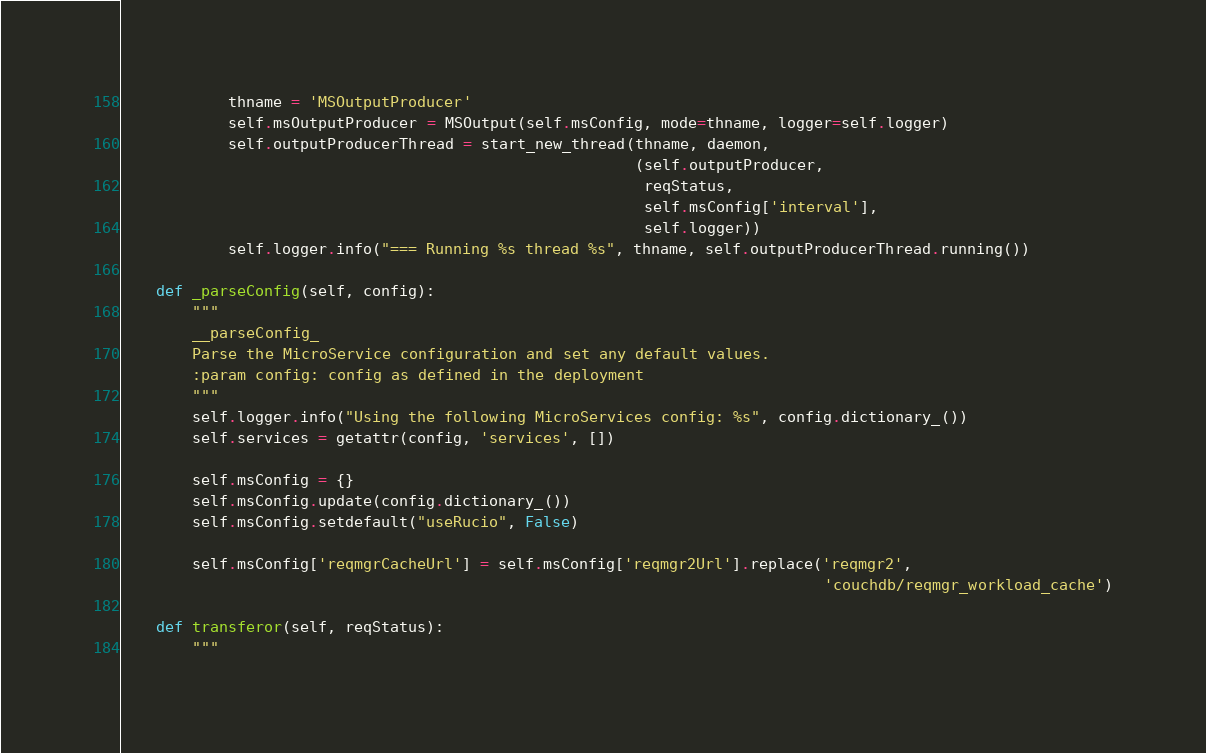Convert code to text. <code><loc_0><loc_0><loc_500><loc_500><_Python_>
            thname = 'MSOutputProducer'
            self.msOutputProducer = MSOutput(self.msConfig, mode=thname, logger=self.logger)
            self.outputProducerThread = start_new_thread(thname, daemon,
                                                         (self.outputProducer,
                                                          reqStatus,
                                                          self.msConfig['interval'],
                                                          self.logger))
            self.logger.info("=== Running %s thread %s", thname, self.outputProducerThread.running())

    def _parseConfig(self, config):
        """
        __parseConfig_
        Parse the MicroService configuration and set any default values.
        :param config: config as defined in the deployment
        """
        self.logger.info("Using the following MicroServices config: %s", config.dictionary_())
        self.services = getattr(config, 'services', [])

        self.msConfig = {}
        self.msConfig.update(config.dictionary_())
        self.msConfig.setdefault("useRucio", False)

        self.msConfig['reqmgrCacheUrl'] = self.msConfig['reqmgr2Url'].replace('reqmgr2',
                                                                              'couchdb/reqmgr_workload_cache')

    def transferor(self, reqStatus):
        """</code> 